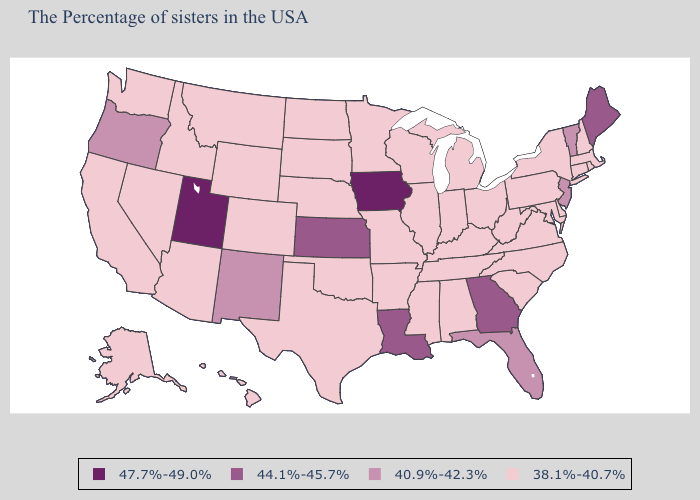What is the lowest value in the Northeast?
Concise answer only. 38.1%-40.7%. Does Oklahoma have the lowest value in the South?
Be succinct. Yes. Is the legend a continuous bar?
Write a very short answer. No. What is the lowest value in the Northeast?
Concise answer only. 38.1%-40.7%. Among the states that border North Carolina , does Georgia have the lowest value?
Write a very short answer. No. Which states have the lowest value in the USA?
Give a very brief answer. Massachusetts, Rhode Island, New Hampshire, Connecticut, New York, Delaware, Maryland, Pennsylvania, Virginia, North Carolina, South Carolina, West Virginia, Ohio, Michigan, Kentucky, Indiana, Alabama, Tennessee, Wisconsin, Illinois, Mississippi, Missouri, Arkansas, Minnesota, Nebraska, Oklahoma, Texas, South Dakota, North Dakota, Wyoming, Colorado, Montana, Arizona, Idaho, Nevada, California, Washington, Alaska, Hawaii. Among the states that border Idaho , does Montana have the lowest value?
Be succinct. Yes. What is the value of Pennsylvania?
Be succinct. 38.1%-40.7%. What is the lowest value in states that border California?
Give a very brief answer. 38.1%-40.7%. Does Utah have the highest value in the West?
Quick response, please. Yes. What is the value of Arkansas?
Keep it brief. 38.1%-40.7%. Name the states that have a value in the range 44.1%-45.7%?
Answer briefly. Maine, Georgia, Louisiana, Kansas. Does the first symbol in the legend represent the smallest category?
Give a very brief answer. No. How many symbols are there in the legend?
Write a very short answer. 4. What is the value of Delaware?
Concise answer only. 38.1%-40.7%. 